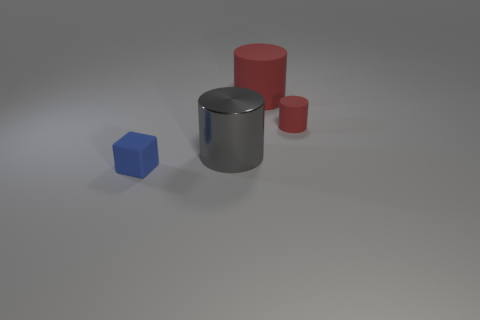Subtract all big rubber cylinders. How many cylinders are left? 2 Subtract all blocks. How many objects are left? 3 Subtract all gray cylinders. How many cylinders are left? 2 Add 3 tiny green matte cylinders. How many objects exist? 7 Add 2 large gray metal cylinders. How many large gray metal cylinders are left? 3 Add 3 small green rubber things. How many small green rubber things exist? 3 Subtract 0 cyan cylinders. How many objects are left? 4 Subtract 1 cylinders. How many cylinders are left? 2 Subtract all cyan cylinders. Subtract all gray spheres. How many cylinders are left? 3 Subtract all cyan cylinders. How many yellow blocks are left? 0 